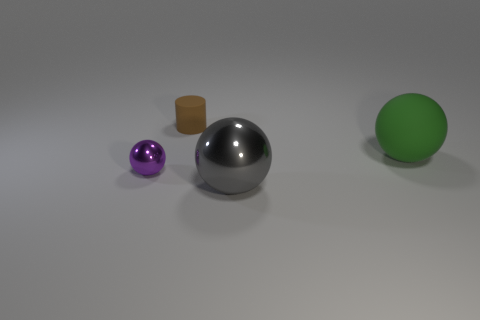What time of day does the lighting in the scene suggest? The lighting in the image does not strongly suggest a particular time of day due to its neutral and soft characteristics, reminiscent of a diffuse light source that could be artificial or natural on an overcast day. 